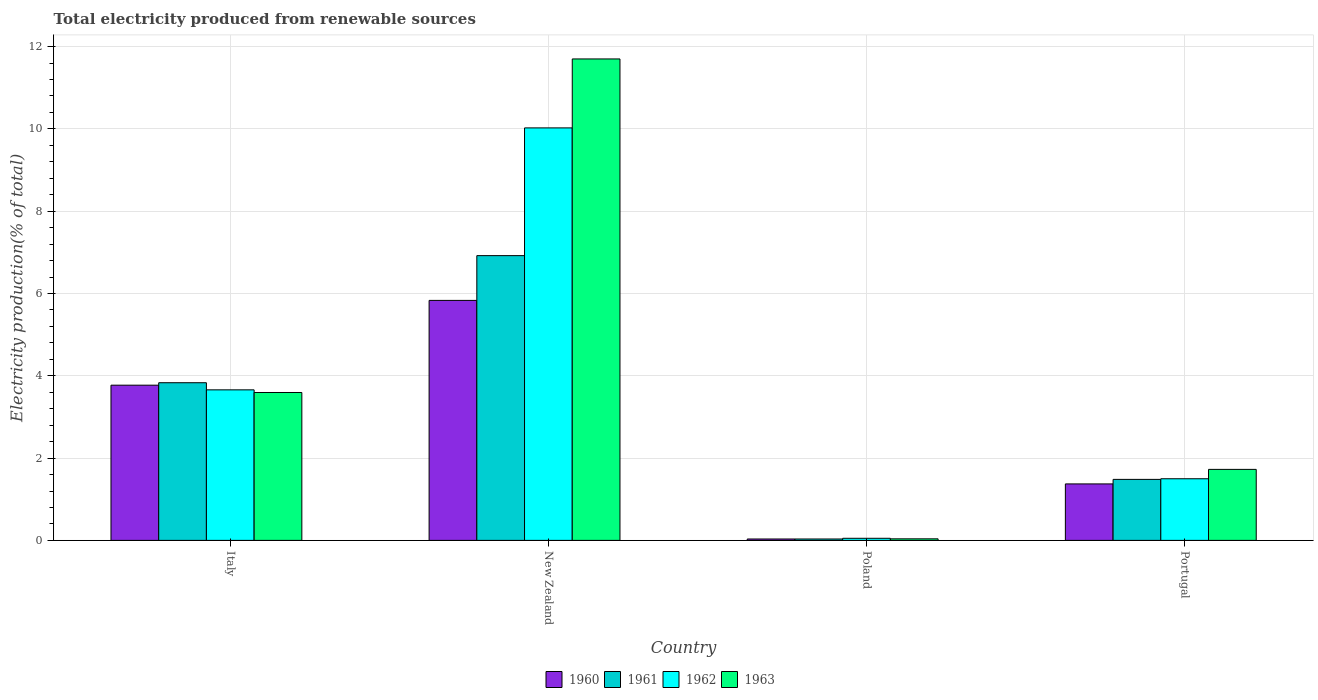How many different coloured bars are there?
Keep it short and to the point. 4. How many groups of bars are there?
Your answer should be very brief. 4. Are the number of bars on each tick of the X-axis equal?
Keep it short and to the point. Yes. How many bars are there on the 4th tick from the left?
Offer a very short reply. 4. How many bars are there on the 4th tick from the right?
Ensure brevity in your answer.  4. What is the label of the 1st group of bars from the left?
Your response must be concise. Italy. In how many cases, is the number of bars for a given country not equal to the number of legend labels?
Make the answer very short. 0. What is the total electricity produced in 1962 in Italy?
Ensure brevity in your answer.  3.66. Across all countries, what is the maximum total electricity produced in 1960?
Provide a succinct answer. 5.83. Across all countries, what is the minimum total electricity produced in 1961?
Give a very brief answer. 0.03. In which country was the total electricity produced in 1960 maximum?
Offer a very short reply. New Zealand. In which country was the total electricity produced in 1963 minimum?
Provide a succinct answer. Poland. What is the total total electricity produced in 1961 in the graph?
Provide a succinct answer. 12.27. What is the difference between the total electricity produced in 1962 in New Zealand and that in Poland?
Your response must be concise. 9.97. What is the difference between the total electricity produced in 1962 in Italy and the total electricity produced in 1960 in Poland?
Your answer should be compact. 3.62. What is the average total electricity produced in 1963 per country?
Provide a short and direct response. 4.26. What is the difference between the total electricity produced of/in 1961 and total electricity produced of/in 1963 in Italy?
Offer a terse response. 0.24. What is the ratio of the total electricity produced in 1960 in New Zealand to that in Portugal?
Offer a very short reply. 4.25. Is the total electricity produced in 1961 in Italy less than that in Portugal?
Your answer should be compact. No. What is the difference between the highest and the second highest total electricity produced in 1960?
Your response must be concise. -2.4. What is the difference between the highest and the lowest total electricity produced in 1960?
Give a very brief answer. 5.8. In how many countries, is the total electricity produced in 1960 greater than the average total electricity produced in 1960 taken over all countries?
Provide a succinct answer. 2. What does the 3rd bar from the left in Poland represents?
Offer a terse response. 1962. What does the 4th bar from the right in New Zealand represents?
Your answer should be very brief. 1960. Is it the case that in every country, the sum of the total electricity produced in 1962 and total electricity produced in 1963 is greater than the total electricity produced in 1961?
Give a very brief answer. Yes. Are all the bars in the graph horizontal?
Your response must be concise. No. What is the difference between two consecutive major ticks on the Y-axis?
Ensure brevity in your answer.  2. Does the graph contain grids?
Your answer should be very brief. Yes. How many legend labels are there?
Provide a short and direct response. 4. What is the title of the graph?
Provide a short and direct response. Total electricity produced from renewable sources. What is the label or title of the X-axis?
Your answer should be very brief. Country. What is the Electricity production(% of total) of 1960 in Italy?
Make the answer very short. 3.77. What is the Electricity production(% of total) in 1961 in Italy?
Keep it short and to the point. 3.83. What is the Electricity production(% of total) in 1962 in Italy?
Make the answer very short. 3.66. What is the Electricity production(% of total) of 1963 in Italy?
Give a very brief answer. 3.59. What is the Electricity production(% of total) in 1960 in New Zealand?
Keep it short and to the point. 5.83. What is the Electricity production(% of total) in 1961 in New Zealand?
Offer a very short reply. 6.92. What is the Electricity production(% of total) in 1962 in New Zealand?
Provide a short and direct response. 10.02. What is the Electricity production(% of total) of 1963 in New Zealand?
Provide a succinct answer. 11.7. What is the Electricity production(% of total) of 1960 in Poland?
Ensure brevity in your answer.  0.03. What is the Electricity production(% of total) of 1961 in Poland?
Give a very brief answer. 0.03. What is the Electricity production(% of total) in 1962 in Poland?
Your answer should be very brief. 0.05. What is the Electricity production(% of total) of 1963 in Poland?
Your answer should be compact. 0.04. What is the Electricity production(% of total) of 1960 in Portugal?
Your answer should be very brief. 1.37. What is the Electricity production(% of total) in 1961 in Portugal?
Give a very brief answer. 1.48. What is the Electricity production(% of total) of 1962 in Portugal?
Your answer should be very brief. 1.5. What is the Electricity production(% of total) in 1963 in Portugal?
Ensure brevity in your answer.  1.73. Across all countries, what is the maximum Electricity production(% of total) in 1960?
Provide a succinct answer. 5.83. Across all countries, what is the maximum Electricity production(% of total) in 1961?
Make the answer very short. 6.92. Across all countries, what is the maximum Electricity production(% of total) in 1962?
Provide a succinct answer. 10.02. Across all countries, what is the maximum Electricity production(% of total) of 1963?
Give a very brief answer. 11.7. Across all countries, what is the minimum Electricity production(% of total) in 1960?
Provide a succinct answer. 0.03. Across all countries, what is the minimum Electricity production(% of total) of 1961?
Keep it short and to the point. 0.03. Across all countries, what is the minimum Electricity production(% of total) of 1962?
Provide a short and direct response. 0.05. Across all countries, what is the minimum Electricity production(% of total) of 1963?
Offer a very short reply. 0.04. What is the total Electricity production(% of total) in 1960 in the graph?
Give a very brief answer. 11.01. What is the total Electricity production(% of total) in 1961 in the graph?
Your answer should be very brief. 12.27. What is the total Electricity production(% of total) in 1962 in the graph?
Make the answer very short. 15.23. What is the total Electricity production(% of total) of 1963 in the graph?
Make the answer very short. 17.06. What is the difference between the Electricity production(% of total) in 1960 in Italy and that in New Zealand?
Your answer should be compact. -2.06. What is the difference between the Electricity production(% of total) in 1961 in Italy and that in New Zealand?
Keep it short and to the point. -3.09. What is the difference between the Electricity production(% of total) in 1962 in Italy and that in New Zealand?
Offer a very short reply. -6.37. What is the difference between the Electricity production(% of total) in 1963 in Italy and that in New Zealand?
Give a very brief answer. -8.11. What is the difference between the Electricity production(% of total) in 1960 in Italy and that in Poland?
Give a very brief answer. 3.74. What is the difference between the Electricity production(% of total) of 1961 in Italy and that in Poland?
Keep it short and to the point. 3.8. What is the difference between the Electricity production(% of total) of 1962 in Italy and that in Poland?
Keep it short and to the point. 3.61. What is the difference between the Electricity production(% of total) in 1963 in Italy and that in Poland?
Give a very brief answer. 3.56. What is the difference between the Electricity production(% of total) of 1960 in Italy and that in Portugal?
Offer a terse response. 2.4. What is the difference between the Electricity production(% of total) of 1961 in Italy and that in Portugal?
Provide a succinct answer. 2.35. What is the difference between the Electricity production(% of total) in 1962 in Italy and that in Portugal?
Make the answer very short. 2.16. What is the difference between the Electricity production(% of total) of 1963 in Italy and that in Portugal?
Ensure brevity in your answer.  1.87. What is the difference between the Electricity production(% of total) in 1960 in New Zealand and that in Poland?
Offer a very short reply. 5.8. What is the difference between the Electricity production(% of total) in 1961 in New Zealand and that in Poland?
Offer a very short reply. 6.89. What is the difference between the Electricity production(% of total) of 1962 in New Zealand and that in Poland?
Ensure brevity in your answer.  9.97. What is the difference between the Electricity production(% of total) in 1963 in New Zealand and that in Poland?
Keep it short and to the point. 11.66. What is the difference between the Electricity production(% of total) in 1960 in New Zealand and that in Portugal?
Give a very brief answer. 4.46. What is the difference between the Electricity production(% of total) of 1961 in New Zealand and that in Portugal?
Your response must be concise. 5.44. What is the difference between the Electricity production(% of total) of 1962 in New Zealand and that in Portugal?
Keep it short and to the point. 8.53. What is the difference between the Electricity production(% of total) in 1963 in New Zealand and that in Portugal?
Offer a very short reply. 9.97. What is the difference between the Electricity production(% of total) in 1960 in Poland and that in Portugal?
Offer a very short reply. -1.34. What is the difference between the Electricity production(% of total) of 1961 in Poland and that in Portugal?
Your answer should be very brief. -1.45. What is the difference between the Electricity production(% of total) of 1962 in Poland and that in Portugal?
Your answer should be very brief. -1.45. What is the difference between the Electricity production(% of total) in 1963 in Poland and that in Portugal?
Keep it short and to the point. -1.69. What is the difference between the Electricity production(% of total) in 1960 in Italy and the Electricity production(% of total) in 1961 in New Zealand?
Offer a very short reply. -3.15. What is the difference between the Electricity production(% of total) of 1960 in Italy and the Electricity production(% of total) of 1962 in New Zealand?
Your response must be concise. -6.25. What is the difference between the Electricity production(% of total) of 1960 in Italy and the Electricity production(% of total) of 1963 in New Zealand?
Make the answer very short. -7.93. What is the difference between the Electricity production(% of total) in 1961 in Italy and the Electricity production(% of total) in 1962 in New Zealand?
Your response must be concise. -6.19. What is the difference between the Electricity production(% of total) of 1961 in Italy and the Electricity production(% of total) of 1963 in New Zealand?
Your response must be concise. -7.87. What is the difference between the Electricity production(% of total) in 1962 in Italy and the Electricity production(% of total) in 1963 in New Zealand?
Offer a terse response. -8.04. What is the difference between the Electricity production(% of total) in 1960 in Italy and the Electricity production(% of total) in 1961 in Poland?
Offer a very short reply. 3.74. What is the difference between the Electricity production(% of total) of 1960 in Italy and the Electricity production(% of total) of 1962 in Poland?
Provide a short and direct response. 3.72. What is the difference between the Electricity production(% of total) of 1960 in Italy and the Electricity production(% of total) of 1963 in Poland?
Your answer should be very brief. 3.73. What is the difference between the Electricity production(% of total) in 1961 in Italy and the Electricity production(% of total) in 1962 in Poland?
Ensure brevity in your answer.  3.78. What is the difference between the Electricity production(% of total) in 1961 in Italy and the Electricity production(% of total) in 1963 in Poland?
Your response must be concise. 3.79. What is the difference between the Electricity production(% of total) of 1962 in Italy and the Electricity production(% of total) of 1963 in Poland?
Offer a very short reply. 3.62. What is the difference between the Electricity production(% of total) of 1960 in Italy and the Electricity production(% of total) of 1961 in Portugal?
Your response must be concise. 2.29. What is the difference between the Electricity production(% of total) of 1960 in Italy and the Electricity production(% of total) of 1962 in Portugal?
Your answer should be compact. 2.27. What is the difference between the Electricity production(% of total) of 1960 in Italy and the Electricity production(% of total) of 1963 in Portugal?
Keep it short and to the point. 2.05. What is the difference between the Electricity production(% of total) of 1961 in Italy and the Electricity production(% of total) of 1962 in Portugal?
Your answer should be compact. 2.33. What is the difference between the Electricity production(% of total) of 1961 in Italy and the Electricity production(% of total) of 1963 in Portugal?
Provide a succinct answer. 2.11. What is the difference between the Electricity production(% of total) of 1962 in Italy and the Electricity production(% of total) of 1963 in Portugal?
Offer a very short reply. 1.93. What is the difference between the Electricity production(% of total) of 1960 in New Zealand and the Electricity production(% of total) of 1961 in Poland?
Your response must be concise. 5.8. What is the difference between the Electricity production(% of total) in 1960 in New Zealand and the Electricity production(% of total) in 1962 in Poland?
Make the answer very short. 5.78. What is the difference between the Electricity production(% of total) of 1960 in New Zealand and the Electricity production(% of total) of 1963 in Poland?
Offer a terse response. 5.79. What is the difference between the Electricity production(% of total) of 1961 in New Zealand and the Electricity production(% of total) of 1962 in Poland?
Give a very brief answer. 6.87. What is the difference between the Electricity production(% of total) in 1961 in New Zealand and the Electricity production(% of total) in 1963 in Poland?
Ensure brevity in your answer.  6.88. What is the difference between the Electricity production(% of total) of 1962 in New Zealand and the Electricity production(% of total) of 1963 in Poland?
Your response must be concise. 9.99. What is the difference between the Electricity production(% of total) of 1960 in New Zealand and the Electricity production(% of total) of 1961 in Portugal?
Offer a very short reply. 4.35. What is the difference between the Electricity production(% of total) in 1960 in New Zealand and the Electricity production(% of total) in 1962 in Portugal?
Your response must be concise. 4.33. What is the difference between the Electricity production(% of total) in 1960 in New Zealand and the Electricity production(% of total) in 1963 in Portugal?
Ensure brevity in your answer.  4.11. What is the difference between the Electricity production(% of total) of 1961 in New Zealand and the Electricity production(% of total) of 1962 in Portugal?
Give a very brief answer. 5.42. What is the difference between the Electricity production(% of total) of 1961 in New Zealand and the Electricity production(% of total) of 1963 in Portugal?
Ensure brevity in your answer.  5.19. What is the difference between the Electricity production(% of total) in 1962 in New Zealand and the Electricity production(% of total) in 1963 in Portugal?
Offer a very short reply. 8.3. What is the difference between the Electricity production(% of total) of 1960 in Poland and the Electricity production(% of total) of 1961 in Portugal?
Offer a terse response. -1.45. What is the difference between the Electricity production(% of total) in 1960 in Poland and the Electricity production(% of total) in 1962 in Portugal?
Your answer should be very brief. -1.46. What is the difference between the Electricity production(% of total) in 1960 in Poland and the Electricity production(% of total) in 1963 in Portugal?
Give a very brief answer. -1.69. What is the difference between the Electricity production(% of total) in 1961 in Poland and the Electricity production(% of total) in 1962 in Portugal?
Ensure brevity in your answer.  -1.46. What is the difference between the Electricity production(% of total) of 1961 in Poland and the Electricity production(% of total) of 1963 in Portugal?
Your answer should be very brief. -1.69. What is the difference between the Electricity production(% of total) in 1962 in Poland and the Electricity production(% of total) in 1963 in Portugal?
Your response must be concise. -1.67. What is the average Electricity production(% of total) of 1960 per country?
Offer a very short reply. 2.75. What is the average Electricity production(% of total) in 1961 per country?
Give a very brief answer. 3.07. What is the average Electricity production(% of total) in 1962 per country?
Offer a very short reply. 3.81. What is the average Electricity production(% of total) in 1963 per country?
Provide a short and direct response. 4.26. What is the difference between the Electricity production(% of total) in 1960 and Electricity production(% of total) in 1961 in Italy?
Offer a very short reply. -0.06. What is the difference between the Electricity production(% of total) in 1960 and Electricity production(% of total) in 1962 in Italy?
Give a very brief answer. 0.11. What is the difference between the Electricity production(% of total) of 1960 and Electricity production(% of total) of 1963 in Italy?
Your answer should be very brief. 0.18. What is the difference between the Electricity production(% of total) of 1961 and Electricity production(% of total) of 1962 in Italy?
Provide a short and direct response. 0.17. What is the difference between the Electricity production(% of total) in 1961 and Electricity production(% of total) in 1963 in Italy?
Offer a very short reply. 0.24. What is the difference between the Electricity production(% of total) in 1962 and Electricity production(% of total) in 1963 in Italy?
Keep it short and to the point. 0.06. What is the difference between the Electricity production(% of total) in 1960 and Electricity production(% of total) in 1961 in New Zealand?
Give a very brief answer. -1.09. What is the difference between the Electricity production(% of total) in 1960 and Electricity production(% of total) in 1962 in New Zealand?
Offer a very short reply. -4.19. What is the difference between the Electricity production(% of total) in 1960 and Electricity production(% of total) in 1963 in New Zealand?
Make the answer very short. -5.87. What is the difference between the Electricity production(% of total) in 1961 and Electricity production(% of total) in 1962 in New Zealand?
Ensure brevity in your answer.  -3.1. What is the difference between the Electricity production(% of total) of 1961 and Electricity production(% of total) of 1963 in New Zealand?
Your answer should be compact. -4.78. What is the difference between the Electricity production(% of total) of 1962 and Electricity production(% of total) of 1963 in New Zealand?
Your answer should be very brief. -1.68. What is the difference between the Electricity production(% of total) in 1960 and Electricity production(% of total) in 1961 in Poland?
Offer a terse response. 0. What is the difference between the Electricity production(% of total) in 1960 and Electricity production(% of total) in 1962 in Poland?
Provide a short and direct response. -0.02. What is the difference between the Electricity production(% of total) in 1960 and Electricity production(% of total) in 1963 in Poland?
Your answer should be compact. -0. What is the difference between the Electricity production(% of total) of 1961 and Electricity production(% of total) of 1962 in Poland?
Provide a short and direct response. -0.02. What is the difference between the Electricity production(% of total) of 1961 and Electricity production(% of total) of 1963 in Poland?
Give a very brief answer. -0. What is the difference between the Electricity production(% of total) of 1962 and Electricity production(% of total) of 1963 in Poland?
Offer a very short reply. 0.01. What is the difference between the Electricity production(% of total) in 1960 and Electricity production(% of total) in 1961 in Portugal?
Keep it short and to the point. -0.11. What is the difference between the Electricity production(% of total) in 1960 and Electricity production(% of total) in 1962 in Portugal?
Ensure brevity in your answer.  -0.13. What is the difference between the Electricity production(% of total) in 1960 and Electricity production(% of total) in 1963 in Portugal?
Provide a succinct answer. -0.35. What is the difference between the Electricity production(% of total) of 1961 and Electricity production(% of total) of 1962 in Portugal?
Your answer should be compact. -0.02. What is the difference between the Electricity production(% of total) in 1961 and Electricity production(% of total) in 1963 in Portugal?
Offer a terse response. -0.24. What is the difference between the Electricity production(% of total) of 1962 and Electricity production(% of total) of 1963 in Portugal?
Make the answer very short. -0.23. What is the ratio of the Electricity production(% of total) of 1960 in Italy to that in New Zealand?
Your response must be concise. 0.65. What is the ratio of the Electricity production(% of total) of 1961 in Italy to that in New Zealand?
Make the answer very short. 0.55. What is the ratio of the Electricity production(% of total) of 1962 in Italy to that in New Zealand?
Your answer should be compact. 0.36. What is the ratio of the Electricity production(% of total) in 1963 in Italy to that in New Zealand?
Your response must be concise. 0.31. What is the ratio of the Electricity production(% of total) of 1960 in Italy to that in Poland?
Offer a terse response. 110.45. What is the ratio of the Electricity production(% of total) of 1961 in Italy to that in Poland?
Provide a short and direct response. 112.3. What is the ratio of the Electricity production(% of total) of 1962 in Italy to that in Poland?
Provide a succinct answer. 71.88. What is the ratio of the Electricity production(% of total) of 1963 in Italy to that in Poland?
Give a very brief answer. 94.84. What is the ratio of the Electricity production(% of total) in 1960 in Italy to that in Portugal?
Ensure brevity in your answer.  2.75. What is the ratio of the Electricity production(% of total) in 1961 in Italy to that in Portugal?
Ensure brevity in your answer.  2.58. What is the ratio of the Electricity production(% of total) of 1962 in Italy to that in Portugal?
Give a very brief answer. 2.44. What is the ratio of the Electricity production(% of total) of 1963 in Italy to that in Portugal?
Your answer should be very brief. 2.08. What is the ratio of the Electricity production(% of total) of 1960 in New Zealand to that in Poland?
Offer a very short reply. 170.79. What is the ratio of the Electricity production(% of total) of 1961 in New Zealand to that in Poland?
Your answer should be very brief. 202.83. What is the ratio of the Electricity production(% of total) of 1962 in New Zealand to that in Poland?
Offer a very short reply. 196.95. What is the ratio of the Electricity production(% of total) in 1963 in New Zealand to that in Poland?
Give a very brief answer. 308.73. What is the ratio of the Electricity production(% of total) in 1960 in New Zealand to that in Portugal?
Your answer should be very brief. 4.25. What is the ratio of the Electricity production(% of total) of 1961 in New Zealand to that in Portugal?
Provide a succinct answer. 4.67. What is the ratio of the Electricity production(% of total) of 1962 in New Zealand to that in Portugal?
Provide a short and direct response. 6.69. What is the ratio of the Electricity production(% of total) of 1963 in New Zealand to that in Portugal?
Provide a short and direct response. 6.78. What is the ratio of the Electricity production(% of total) of 1960 in Poland to that in Portugal?
Your answer should be compact. 0.02. What is the ratio of the Electricity production(% of total) of 1961 in Poland to that in Portugal?
Offer a terse response. 0.02. What is the ratio of the Electricity production(% of total) in 1962 in Poland to that in Portugal?
Provide a short and direct response. 0.03. What is the ratio of the Electricity production(% of total) in 1963 in Poland to that in Portugal?
Your answer should be compact. 0.02. What is the difference between the highest and the second highest Electricity production(% of total) of 1960?
Offer a terse response. 2.06. What is the difference between the highest and the second highest Electricity production(% of total) in 1961?
Your response must be concise. 3.09. What is the difference between the highest and the second highest Electricity production(% of total) of 1962?
Ensure brevity in your answer.  6.37. What is the difference between the highest and the second highest Electricity production(% of total) of 1963?
Make the answer very short. 8.11. What is the difference between the highest and the lowest Electricity production(% of total) of 1960?
Provide a short and direct response. 5.8. What is the difference between the highest and the lowest Electricity production(% of total) in 1961?
Keep it short and to the point. 6.89. What is the difference between the highest and the lowest Electricity production(% of total) in 1962?
Your response must be concise. 9.97. What is the difference between the highest and the lowest Electricity production(% of total) in 1963?
Keep it short and to the point. 11.66. 